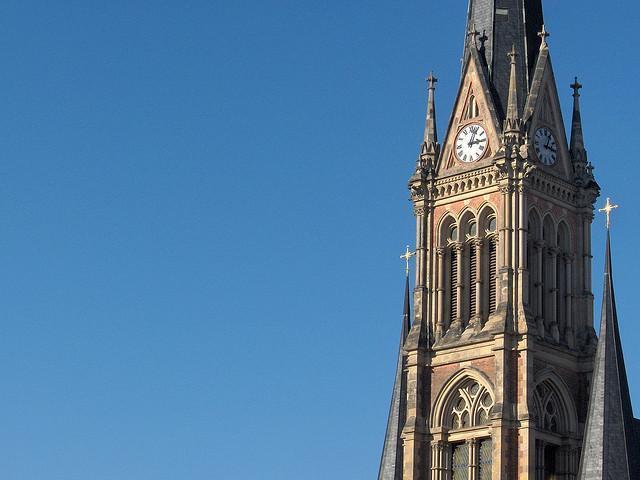How many crosses can be seen?
Give a very brief answer. 7. 